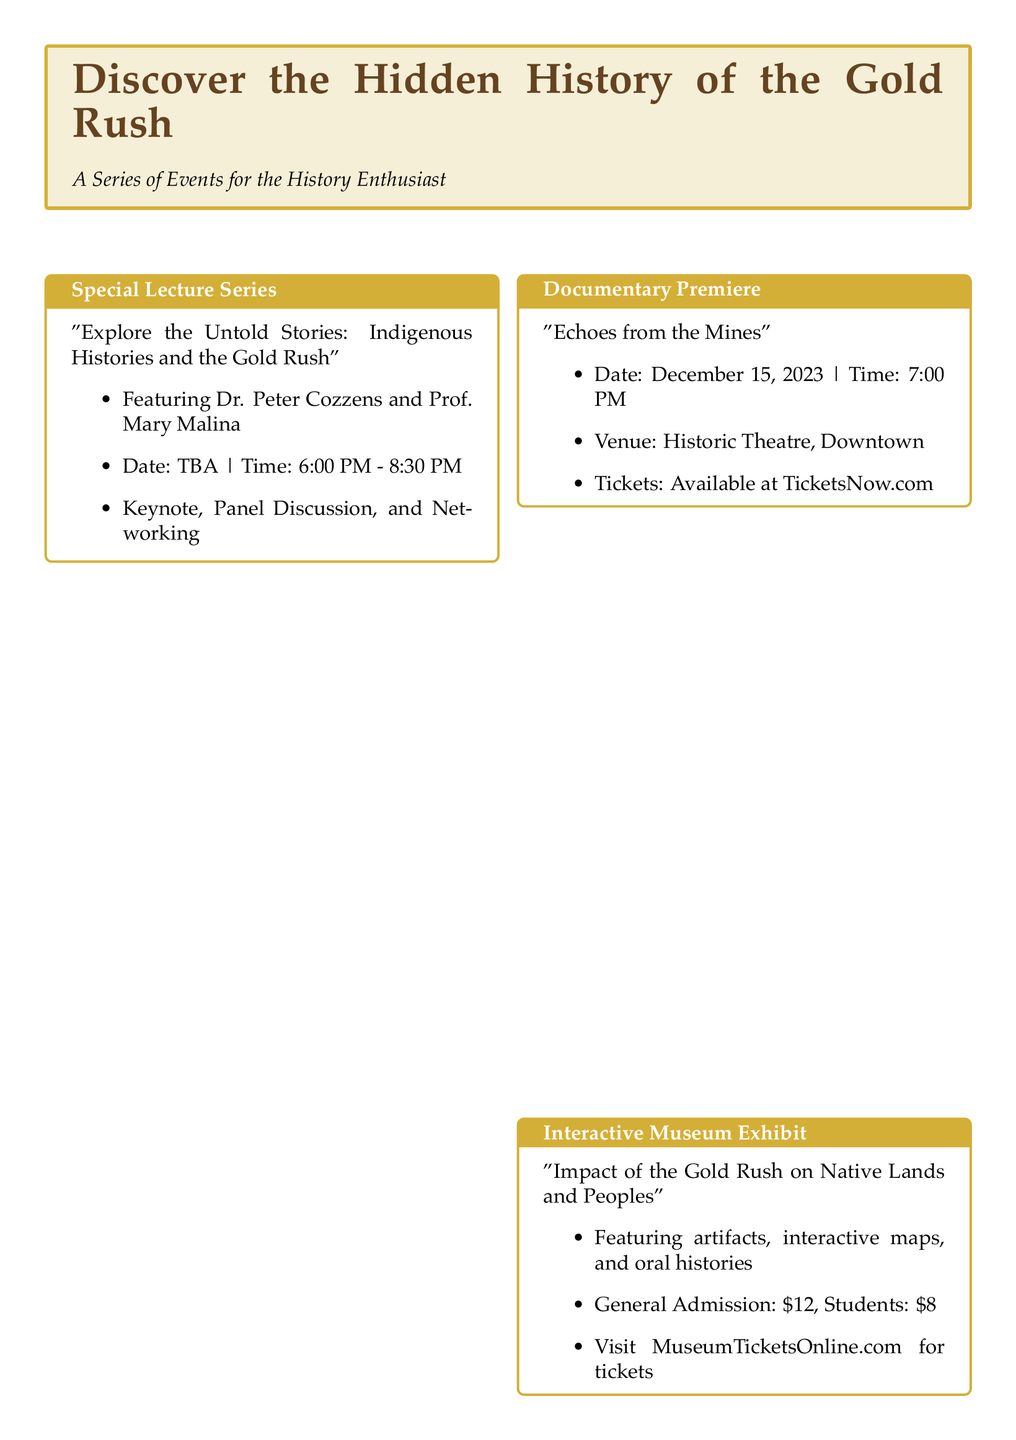What is the title of the special lecture series? The title of the special lecture series is provided in the document as "Explore the Untold Stories: Indigenous Histories and the Gold Rush."
Answer: Explore the Untold Stories: Indigenous Histories and the Gold Rush Who are the featured speakers for the Historical Research Seminar? The featured speakers for the Historical Research Seminar are mentioned as Dr. Linda Powell and Prof. James Ortega.
Answer: Dr. Linda Powell and Prof. James Ortega What is the ticket price for students at the Interactive Museum Exhibit? The document specifies that the ticket price for students at the Interactive Museum Exhibit is $8.
Answer: $8 When will the documentary "Echoes from the Mines" premiere? The document states that the documentary "Echoes from the Mines" will premiere on December 15, 2023.
Answer: December 15, 2023 What is the registration deadline for the Historical Research Seminar? The registration deadline for the Historical Research Seminar is mentioned as November 25, 2023.
Answer: November 25, 2023 What type of event is the "Native Voices of the Gold Rush" gathering? The document describes the "Native Voices of the Gold Rush" gathering as a book launch event.
Answer: Book Launch Event What time does the special lecture series start? The starting time for the special lecture series is indicated as 6:00 PM.
Answer: 6:00 PM What is the main focus of the Interactive Museum Exhibit? The main focus of the Interactive Museum Exhibit is to highlight the impact of the Gold Rush on Native Lands and Peoples.
Answer: Impact of the Gold Rush on Native Lands and Peoples 